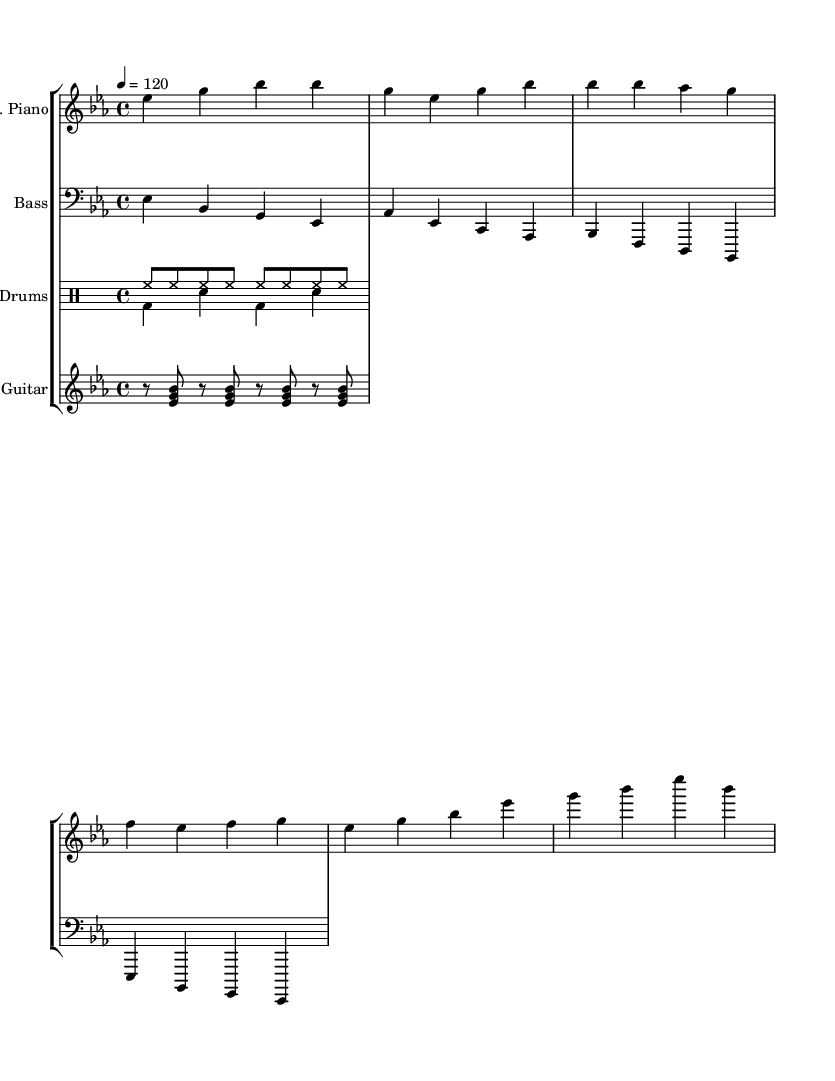What is the key signature of this music? The key signature is E flat major, which features three flats: B flat, E flat, and A flat. This can be confirmed by looking at the key signature indicated at the beginning of the score.
Answer: E flat major What is the time signature of the piece? The time signature is 4/4, which indicates that there are four beats in each measure, and the quarter note gets one beat. This is visible at the beginning of the score.
Answer: 4/4 What is the tempo marking of the composition? The tempo marking is 120 beats per minute. This shows the speed at which the piece should be played and is found in the tempo indication at the beginning.
Answer: 120 How many parts are included in this score? There are four parts included: electric piano, bass guitar, drums, and rhythm guitar. This can be determined by counting the distinct staff sections indicated in the score.
Answer: Four What is the pattern of the bass line? The bass line features a repeated pattern that spans a sequence of four measures, emphasizing the root notes of the chords and creating a solid foundational groove typical in disco music. This can be observed in the bass guitar staff.
Answer: Repeated pattern What is a distinctive characteristic of the rhythm guitar part? The rhythm guitar part utilizes syncopated chords, which are typical for disco music, creating a lively and danceable rhythm. This can be identified by the rhythmic notation and chords indicated in the rhythm guitar staff.
Answer: Syncopated chords What type of drum pattern is used in the piece? The drum pattern consists of a steady hi-hat rhythm combined with a bass and snare pattern typical for disco tracks, providing a driving beat that enhances the dance atmosphere. This can be seen in the drum staff section.
Answer: Steady hi-hat with bass and snare 